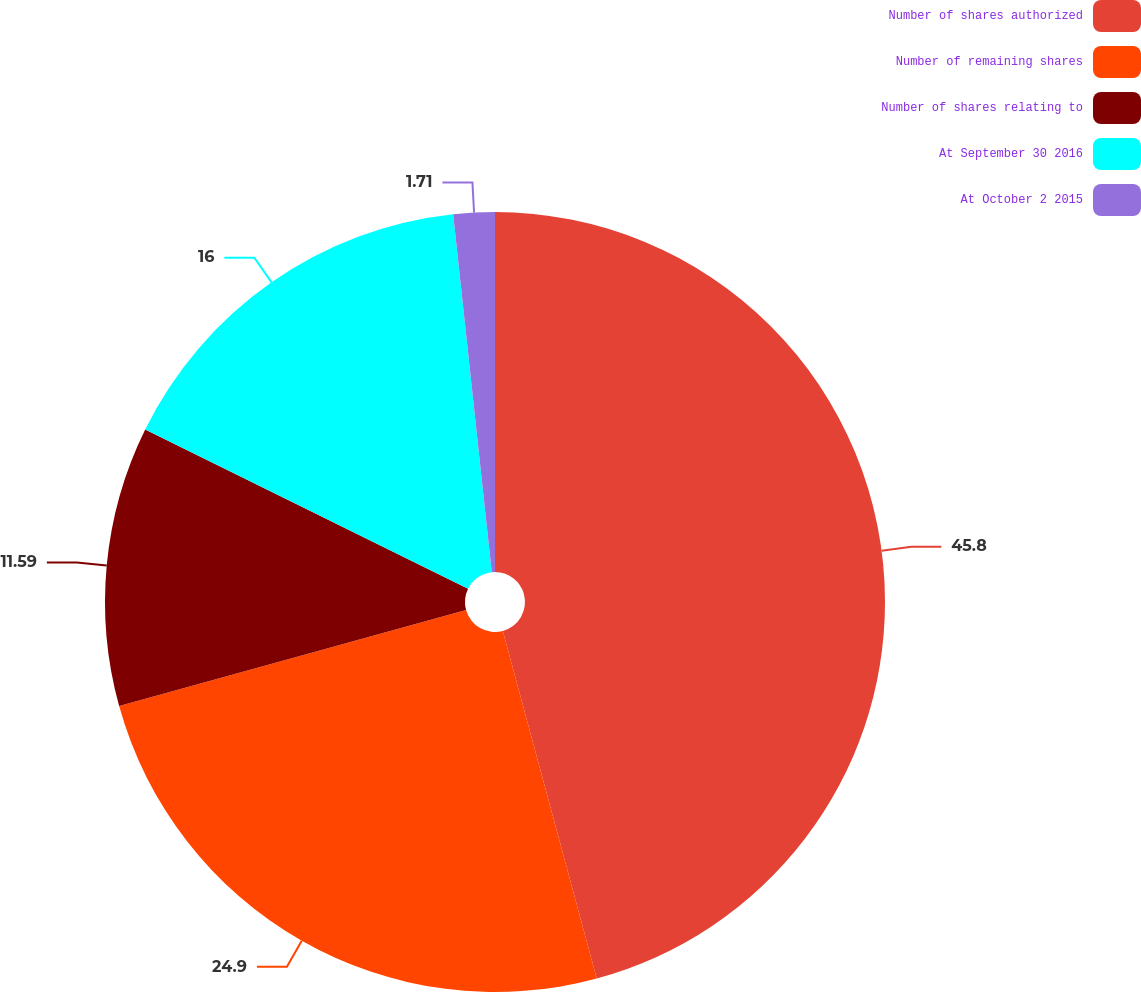Convert chart to OTSL. <chart><loc_0><loc_0><loc_500><loc_500><pie_chart><fcel>Number of shares authorized<fcel>Number of remaining shares<fcel>Number of shares relating to<fcel>At September 30 2016<fcel>At October 2 2015<nl><fcel>45.8%<fcel>24.9%<fcel>11.59%<fcel>16.0%<fcel>1.71%<nl></chart> 